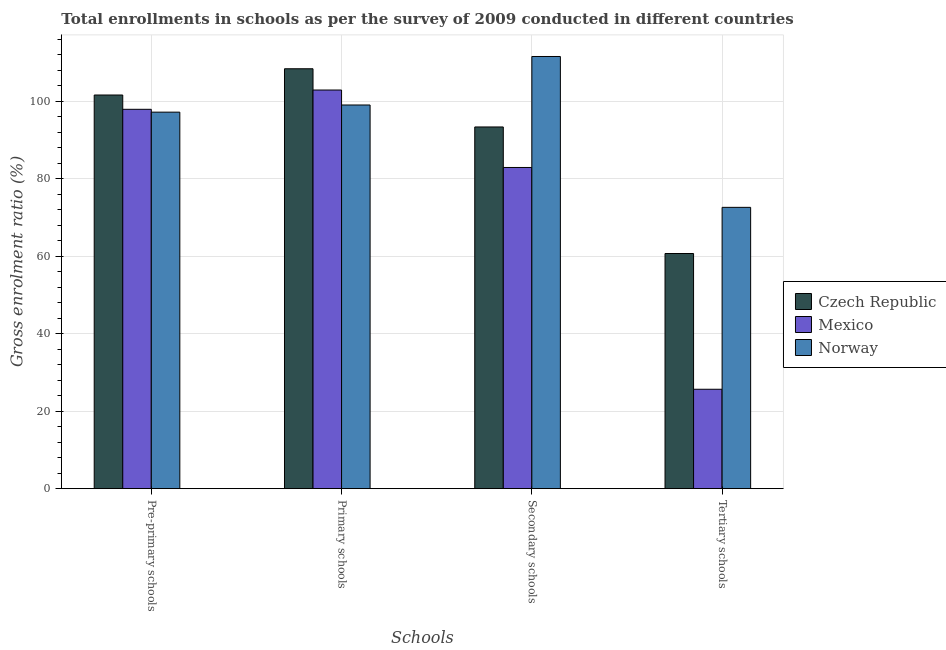How many groups of bars are there?
Offer a terse response. 4. Are the number of bars per tick equal to the number of legend labels?
Make the answer very short. Yes. How many bars are there on the 3rd tick from the left?
Keep it short and to the point. 3. What is the label of the 2nd group of bars from the left?
Keep it short and to the point. Primary schools. What is the gross enrolment ratio in pre-primary schools in Mexico?
Your response must be concise. 97.89. Across all countries, what is the maximum gross enrolment ratio in tertiary schools?
Make the answer very short. 72.59. Across all countries, what is the minimum gross enrolment ratio in pre-primary schools?
Your answer should be compact. 97.16. In which country was the gross enrolment ratio in primary schools maximum?
Your response must be concise. Czech Republic. What is the total gross enrolment ratio in pre-primary schools in the graph?
Your answer should be compact. 296.63. What is the difference between the gross enrolment ratio in tertiary schools in Czech Republic and that in Norway?
Make the answer very short. -11.91. What is the difference between the gross enrolment ratio in primary schools in Norway and the gross enrolment ratio in pre-primary schools in Czech Republic?
Offer a terse response. -2.58. What is the average gross enrolment ratio in tertiary schools per country?
Make the answer very short. 52.98. What is the difference between the gross enrolment ratio in primary schools and gross enrolment ratio in tertiary schools in Czech Republic?
Offer a terse response. 47.67. What is the ratio of the gross enrolment ratio in tertiary schools in Czech Republic to that in Norway?
Give a very brief answer. 0.84. What is the difference between the highest and the second highest gross enrolment ratio in pre-primary schools?
Provide a succinct answer. 3.69. What is the difference between the highest and the lowest gross enrolment ratio in secondary schools?
Offer a terse response. 28.64. Is the sum of the gross enrolment ratio in pre-primary schools in Czech Republic and Norway greater than the maximum gross enrolment ratio in tertiary schools across all countries?
Your answer should be compact. Yes. What does the 2nd bar from the right in Tertiary schools represents?
Your answer should be compact. Mexico. Is it the case that in every country, the sum of the gross enrolment ratio in pre-primary schools and gross enrolment ratio in primary schools is greater than the gross enrolment ratio in secondary schools?
Your answer should be very brief. Yes. How many bars are there?
Give a very brief answer. 12. Are all the bars in the graph horizontal?
Your answer should be very brief. No. How many countries are there in the graph?
Provide a succinct answer. 3. Where does the legend appear in the graph?
Keep it short and to the point. Center right. How are the legend labels stacked?
Provide a succinct answer. Vertical. What is the title of the graph?
Keep it short and to the point. Total enrollments in schools as per the survey of 2009 conducted in different countries. Does "High income" appear as one of the legend labels in the graph?
Your response must be concise. No. What is the label or title of the X-axis?
Offer a very short reply. Schools. What is the Gross enrolment ratio (%) in Czech Republic in Pre-primary schools?
Give a very brief answer. 101.58. What is the Gross enrolment ratio (%) of Mexico in Pre-primary schools?
Your response must be concise. 97.89. What is the Gross enrolment ratio (%) of Norway in Pre-primary schools?
Provide a succinct answer. 97.16. What is the Gross enrolment ratio (%) of Czech Republic in Primary schools?
Your answer should be compact. 108.35. What is the Gross enrolment ratio (%) in Mexico in Primary schools?
Your response must be concise. 102.87. What is the Gross enrolment ratio (%) in Norway in Primary schools?
Your response must be concise. 99. What is the Gross enrolment ratio (%) of Czech Republic in Secondary schools?
Make the answer very short. 93.33. What is the Gross enrolment ratio (%) in Mexico in Secondary schools?
Ensure brevity in your answer.  82.88. What is the Gross enrolment ratio (%) in Norway in Secondary schools?
Your response must be concise. 111.52. What is the Gross enrolment ratio (%) in Czech Republic in Tertiary schools?
Ensure brevity in your answer.  60.68. What is the Gross enrolment ratio (%) in Mexico in Tertiary schools?
Offer a very short reply. 25.65. What is the Gross enrolment ratio (%) in Norway in Tertiary schools?
Ensure brevity in your answer.  72.59. Across all Schools, what is the maximum Gross enrolment ratio (%) in Czech Republic?
Make the answer very short. 108.35. Across all Schools, what is the maximum Gross enrolment ratio (%) in Mexico?
Ensure brevity in your answer.  102.87. Across all Schools, what is the maximum Gross enrolment ratio (%) in Norway?
Give a very brief answer. 111.52. Across all Schools, what is the minimum Gross enrolment ratio (%) of Czech Republic?
Offer a very short reply. 60.68. Across all Schools, what is the minimum Gross enrolment ratio (%) of Mexico?
Ensure brevity in your answer.  25.65. Across all Schools, what is the minimum Gross enrolment ratio (%) of Norway?
Your answer should be very brief. 72.59. What is the total Gross enrolment ratio (%) of Czech Republic in the graph?
Your response must be concise. 363.95. What is the total Gross enrolment ratio (%) in Mexico in the graph?
Your answer should be very brief. 309.29. What is the total Gross enrolment ratio (%) of Norway in the graph?
Make the answer very short. 380.27. What is the difference between the Gross enrolment ratio (%) in Czech Republic in Pre-primary schools and that in Primary schools?
Provide a succinct answer. -6.77. What is the difference between the Gross enrolment ratio (%) in Mexico in Pre-primary schools and that in Primary schools?
Your answer should be very brief. -4.98. What is the difference between the Gross enrolment ratio (%) of Norway in Pre-primary schools and that in Primary schools?
Provide a short and direct response. -1.85. What is the difference between the Gross enrolment ratio (%) in Czech Republic in Pre-primary schools and that in Secondary schools?
Provide a succinct answer. 8.25. What is the difference between the Gross enrolment ratio (%) of Mexico in Pre-primary schools and that in Secondary schools?
Offer a terse response. 15.01. What is the difference between the Gross enrolment ratio (%) in Norway in Pre-primary schools and that in Secondary schools?
Provide a short and direct response. -14.36. What is the difference between the Gross enrolment ratio (%) of Czech Republic in Pre-primary schools and that in Tertiary schools?
Offer a very short reply. 40.9. What is the difference between the Gross enrolment ratio (%) of Mexico in Pre-primary schools and that in Tertiary schools?
Your answer should be compact. 72.24. What is the difference between the Gross enrolment ratio (%) in Norway in Pre-primary schools and that in Tertiary schools?
Ensure brevity in your answer.  24.57. What is the difference between the Gross enrolment ratio (%) of Czech Republic in Primary schools and that in Secondary schools?
Offer a terse response. 15.02. What is the difference between the Gross enrolment ratio (%) in Mexico in Primary schools and that in Secondary schools?
Offer a terse response. 19.99. What is the difference between the Gross enrolment ratio (%) in Norway in Primary schools and that in Secondary schools?
Make the answer very short. -12.52. What is the difference between the Gross enrolment ratio (%) in Czech Republic in Primary schools and that in Tertiary schools?
Offer a terse response. 47.67. What is the difference between the Gross enrolment ratio (%) in Mexico in Primary schools and that in Tertiary schools?
Your answer should be very brief. 77.21. What is the difference between the Gross enrolment ratio (%) of Norway in Primary schools and that in Tertiary schools?
Make the answer very short. 26.41. What is the difference between the Gross enrolment ratio (%) of Czech Republic in Secondary schools and that in Tertiary schools?
Provide a short and direct response. 32.65. What is the difference between the Gross enrolment ratio (%) in Mexico in Secondary schools and that in Tertiary schools?
Provide a succinct answer. 57.23. What is the difference between the Gross enrolment ratio (%) of Norway in Secondary schools and that in Tertiary schools?
Offer a very short reply. 38.93. What is the difference between the Gross enrolment ratio (%) in Czech Republic in Pre-primary schools and the Gross enrolment ratio (%) in Mexico in Primary schools?
Give a very brief answer. -1.29. What is the difference between the Gross enrolment ratio (%) of Czech Republic in Pre-primary schools and the Gross enrolment ratio (%) of Norway in Primary schools?
Keep it short and to the point. 2.58. What is the difference between the Gross enrolment ratio (%) of Mexico in Pre-primary schools and the Gross enrolment ratio (%) of Norway in Primary schools?
Give a very brief answer. -1.11. What is the difference between the Gross enrolment ratio (%) in Czech Republic in Pre-primary schools and the Gross enrolment ratio (%) in Mexico in Secondary schools?
Offer a terse response. 18.7. What is the difference between the Gross enrolment ratio (%) of Czech Republic in Pre-primary schools and the Gross enrolment ratio (%) of Norway in Secondary schools?
Offer a terse response. -9.94. What is the difference between the Gross enrolment ratio (%) of Mexico in Pre-primary schools and the Gross enrolment ratio (%) of Norway in Secondary schools?
Keep it short and to the point. -13.63. What is the difference between the Gross enrolment ratio (%) in Czech Republic in Pre-primary schools and the Gross enrolment ratio (%) in Mexico in Tertiary schools?
Your response must be concise. 75.93. What is the difference between the Gross enrolment ratio (%) of Czech Republic in Pre-primary schools and the Gross enrolment ratio (%) of Norway in Tertiary schools?
Make the answer very short. 28.99. What is the difference between the Gross enrolment ratio (%) of Mexico in Pre-primary schools and the Gross enrolment ratio (%) of Norway in Tertiary schools?
Offer a very short reply. 25.3. What is the difference between the Gross enrolment ratio (%) of Czech Republic in Primary schools and the Gross enrolment ratio (%) of Mexico in Secondary schools?
Your answer should be very brief. 25.47. What is the difference between the Gross enrolment ratio (%) of Czech Republic in Primary schools and the Gross enrolment ratio (%) of Norway in Secondary schools?
Ensure brevity in your answer.  -3.17. What is the difference between the Gross enrolment ratio (%) of Mexico in Primary schools and the Gross enrolment ratio (%) of Norway in Secondary schools?
Offer a terse response. -8.65. What is the difference between the Gross enrolment ratio (%) of Czech Republic in Primary schools and the Gross enrolment ratio (%) of Mexico in Tertiary schools?
Keep it short and to the point. 82.7. What is the difference between the Gross enrolment ratio (%) of Czech Republic in Primary schools and the Gross enrolment ratio (%) of Norway in Tertiary schools?
Offer a terse response. 35.76. What is the difference between the Gross enrolment ratio (%) in Mexico in Primary schools and the Gross enrolment ratio (%) in Norway in Tertiary schools?
Give a very brief answer. 30.27. What is the difference between the Gross enrolment ratio (%) of Czech Republic in Secondary schools and the Gross enrolment ratio (%) of Mexico in Tertiary schools?
Ensure brevity in your answer.  67.68. What is the difference between the Gross enrolment ratio (%) of Czech Republic in Secondary schools and the Gross enrolment ratio (%) of Norway in Tertiary schools?
Make the answer very short. 20.74. What is the difference between the Gross enrolment ratio (%) of Mexico in Secondary schools and the Gross enrolment ratio (%) of Norway in Tertiary schools?
Keep it short and to the point. 10.29. What is the average Gross enrolment ratio (%) of Czech Republic per Schools?
Keep it short and to the point. 90.99. What is the average Gross enrolment ratio (%) in Mexico per Schools?
Your response must be concise. 77.32. What is the average Gross enrolment ratio (%) of Norway per Schools?
Provide a short and direct response. 95.07. What is the difference between the Gross enrolment ratio (%) of Czech Republic and Gross enrolment ratio (%) of Mexico in Pre-primary schools?
Provide a short and direct response. 3.69. What is the difference between the Gross enrolment ratio (%) of Czech Republic and Gross enrolment ratio (%) of Norway in Pre-primary schools?
Make the answer very short. 4.42. What is the difference between the Gross enrolment ratio (%) of Mexico and Gross enrolment ratio (%) of Norway in Pre-primary schools?
Provide a succinct answer. 0.73. What is the difference between the Gross enrolment ratio (%) of Czech Republic and Gross enrolment ratio (%) of Mexico in Primary schools?
Provide a succinct answer. 5.48. What is the difference between the Gross enrolment ratio (%) in Czech Republic and Gross enrolment ratio (%) in Norway in Primary schools?
Your response must be concise. 9.35. What is the difference between the Gross enrolment ratio (%) of Mexico and Gross enrolment ratio (%) of Norway in Primary schools?
Keep it short and to the point. 3.86. What is the difference between the Gross enrolment ratio (%) of Czech Republic and Gross enrolment ratio (%) of Mexico in Secondary schools?
Your response must be concise. 10.45. What is the difference between the Gross enrolment ratio (%) of Czech Republic and Gross enrolment ratio (%) of Norway in Secondary schools?
Make the answer very short. -18.19. What is the difference between the Gross enrolment ratio (%) in Mexico and Gross enrolment ratio (%) in Norway in Secondary schools?
Your answer should be compact. -28.64. What is the difference between the Gross enrolment ratio (%) in Czech Republic and Gross enrolment ratio (%) in Mexico in Tertiary schools?
Ensure brevity in your answer.  35.03. What is the difference between the Gross enrolment ratio (%) of Czech Republic and Gross enrolment ratio (%) of Norway in Tertiary schools?
Offer a very short reply. -11.91. What is the difference between the Gross enrolment ratio (%) in Mexico and Gross enrolment ratio (%) in Norway in Tertiary schools?
Your answer should be compact. -46.94. What is the ratio of the Gross enrolment ratio (%) in Czech Republic in Pre-primary schools to that in Primary schools?
Provide a succinct answer. 0.94. What is the ratio of the Gross enrolment ratio (%) of Mexico in Pre-primary schools to that in Primary schools?
Provide a short and direct response. 0.95. What is the ratio of the Gross enrolment ratio (%) in Norway in Pre-primary schools to that in Primary schools?
Give a very brief answer. 0.98. What is the ratio of the Gross enrolment ratio (%) in Czech Republic in Pre-primary schools to that in Secondary schools?
Make the answer very short. 1.09. What is the ratio of the Gross enrolment ratio (%) in Mexico in Pre-primary schools to that in Secondary schools?
Ensure brevity in your answer.  1.18. What is the ratio of the Gross enrolment ratio (%) in Norway in Pre-primary schools to that in Secondary schools?
Give a very brief answer. 0.87. What is the ratio of the Gross enrolment ratio (%) of Czech Republic in Pre-primary schools to that in Tertiary schools?
Your answer should be compact. 1.67. What is the ratio of the Gross enrolment ratio (%) of Mexico in Pre-primary schools to that in Tertiary schools?
Keep it short and to the point. 3.82. What is the ratio of the Gross enrolment ratio (%) of Norway in Pre-primary schools to that in Tertiary schools?
Your response must be concise. 1.34. What is the ratio of the Gross enrolment ratio (%) of Czech Republic in Primary schools to that in Secondary schools?
Offer a very short reply. 1.16. What is the ratio of the Gross enrolment ratio (%) in Mexico in Primary schools to that in Secondary schools?
Make the answer very short. 1.24. What is the ratio of the Gross enrolment ratio (%) of Norway in Primary schools to that in Secondary schools?
Keep it short and to the point. 0.89. What is the ratio of the Gross enrolment ratio (%) of Czech Republic in Primary schools to that in Tertiary schools?
Your response must be concise. 1.79. What is the ratio of the Gross enrolment ratio (%) in Mexico in Primary schools to that in Tertiary schools?
Your response must be concise. 4.01. What is the ratio of the Gross enrolment ratio (%) of Norway in Primary schools to that in Tertiary schools?
Offer a terse response. 1.36. What is the ratio of the Gross enrolment ratio (%) in Czech Republic in Secondary schools to that in Tertiary schools?
Give a very brief answer. 1.54. What is the ratio of the Gross enrolment ratio (%) in Mexico in Secondary schools to that in Tertiary schools?
Provide a short and direct response. 3.23. What is the ratio of the Gross enrolment ratio (%) in Norway in Secondary schools to that in Tertiary schools?
Provide a succinct answer. 1.54. What is the difference between the highest and the second highest Gross enrolment ratio (%) in Czech Republic?
Make the answer very short. 6.77. What is the difference between the highest and the second highest Gross enrolment ratio (%) in Mexico?
Your answer should be compact. 4.98. What is the difference between the highest and the second highest Gross enrolment ratio (%) of Norway?
Give a very brief answer. 12.52. What is the difference between the highest and the lowest Gross enrolment ratio (%) in Czech Republic?
Your answer should be very brief. 47.67. What is the difference between the highest and the lowest Gross enrolment ratio (%) of Mexico?
Your answer should be compact. 77.21. What is the difference between the highest and the lowest Gross enrolment ratio (%) of Norway?
Offer a very short reply. 38.93. 